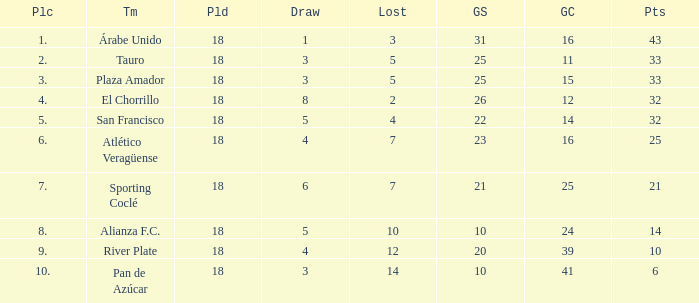How many goals were conceded by teams with 32 points, more than 2 losses and more than 22 goals scored? 0.0. 